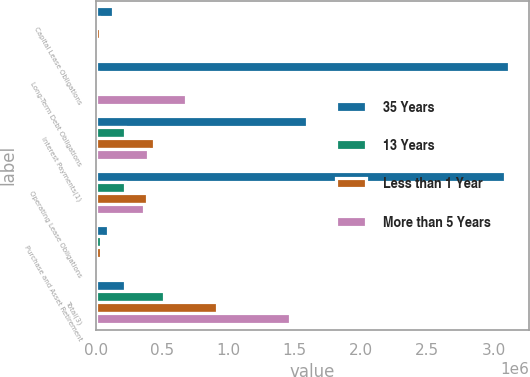Convert chart. <chart><loc_0><loc_0><loc_500><loc_500><stacked_bar_chart><ecel><fcel>Capital Lease Obligations<fcel>Long-Term Debt Obligations<fcel>Interest Payments(1)<fcel>Operating Lease Obligations<fcel>Purchase and Asset Retirement<fcel>Total(3)<nl><fcel>35 Years<fcel>131687<fcel>3.11227e+06<fcel>1.59548e+06<fcel>3.08295e+06<fcel>91409<fcel>221949<nl><fcel>13 Years<fcel>21042<fcel>14709<fcel>220988<fcel>221949<fcel>36483<fcel>515171<nl><fcel>Less than 1 Year<fcel>34262<fcel>11858<fcel>438387<fcel>389833<fcel>41408<fcel>915748<nl><fcel>More than 5 Years<fcel>26093<fcel>677570<fcel>392234<fcel>365621<fcel>4169<fcel>1.46569e+06<nl></chart> 